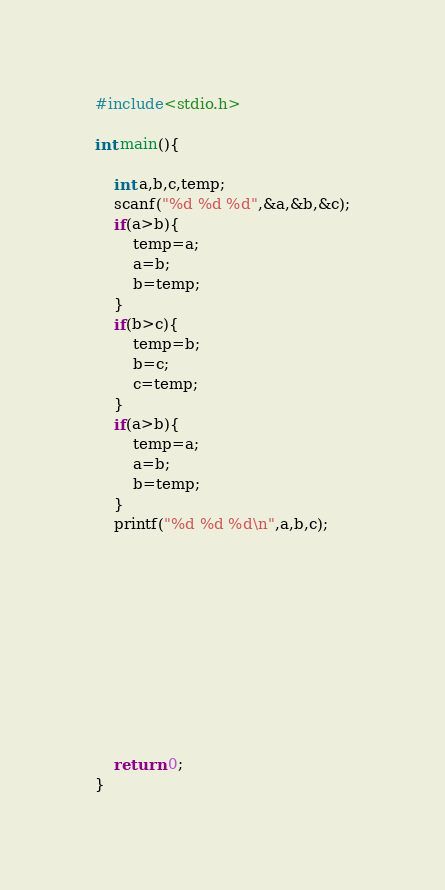<code> <loc_0><loc_0><loc_500><loc_500><_C_>#include<stdio.h>

int main(){
    
    int a,b,c,temp;
    scanf("%d %d %d",&a,&b,&c);
    if(a>b){
        temp=a;
        a=b;
        b=temp;
    }
    if(b>c){
        temp=b;
        b=c;
        c=temp;
    }
    if(a>b){
        temp=a;
        a=b;
        b=temp;
    }
    printf("%d %d %d\n",a,b,c);
    
    
    
    
    
    
    
    
    
    
    
    return 0;
}
</code> 